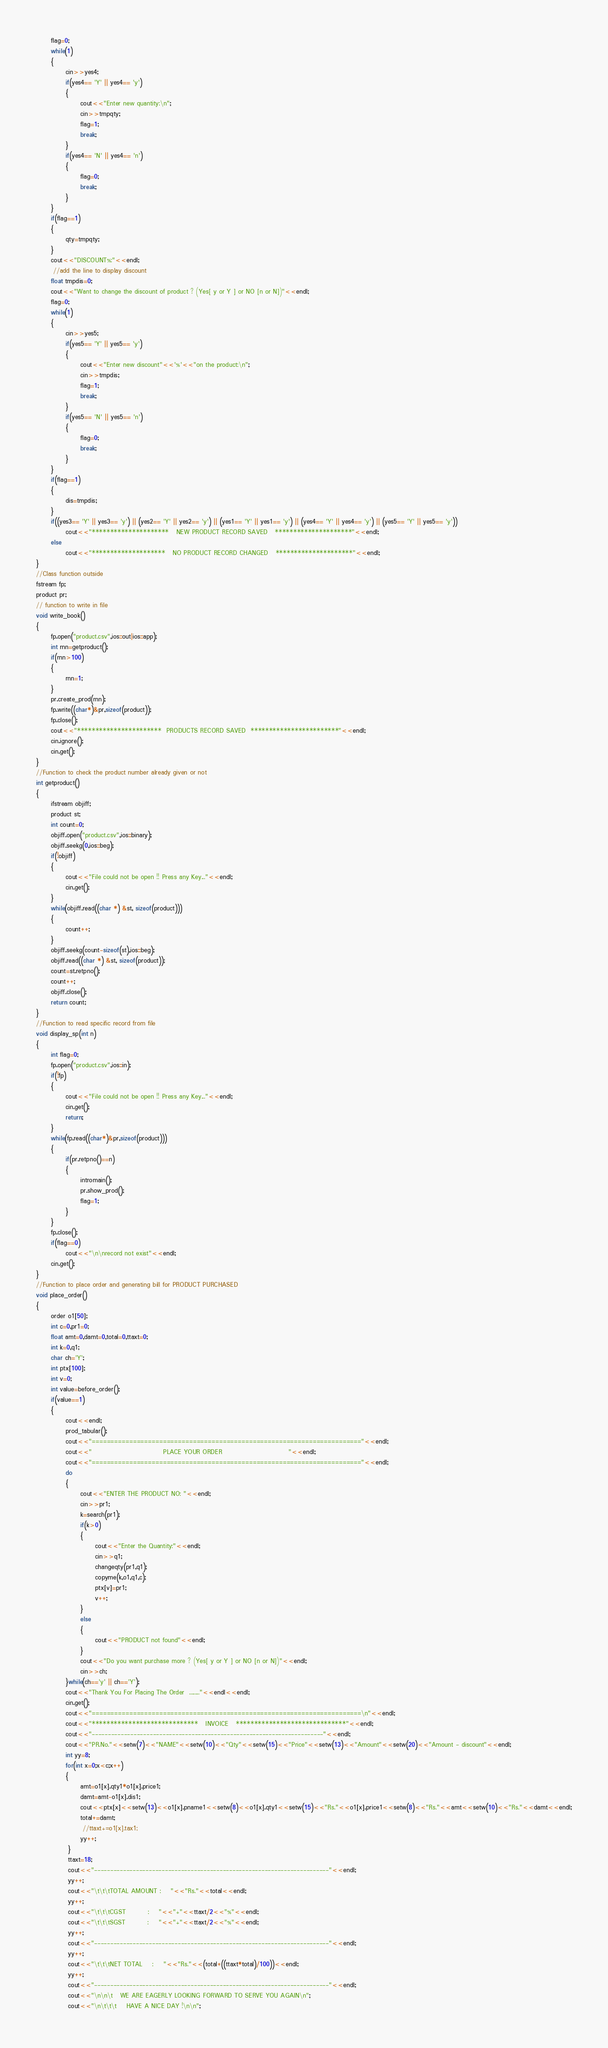Convert code to text. <code><loc_0><loc_0><loc_500><loc_500><_C++_>      flag=0;
      while(1)
      {
            cin>>yes4;
            if(yes4== 'Y' || yes4== 'y')
            {
                  cout<<"Enter new quantity:\n";
                  cin>>tmpqty;
                  flag=1;
                  break;
            }
            if(yes4== 'N' || yes4== 'n')
            {
                  flag=0;
                  break;
            }
      }
      if(flag==1)
      {
            qty=tmpqty;
      }
      cout<<"DISCOUNT%:"<<endl;
       //add the line to display discount
      float tmpdis=0;
      cout<<"Want to change the discount of product ? (Yes[ y or Y ] or NO [n or N])"<<endl;
      flag=0;
      while(1)
      {
            cin>>yes5;
            if(yes5== 'Y' || yes5== 'y')
            {
                  cout<<"Enter new discount"<<'%'<<"on the product:\n";
                  cin>>tmpdis;
                  flag=1;
                  break;
            }
            if(yes5== 'N' || yes5== 'n')
            {
                  flag=0;
                  break;
            }
      }
      if(flag==1)
      {
            dis=tmpdis;
      }
      if((yes3== 'Y' || yes3== 'y') || (yes2== 'Y' || yes2== 'y') || (yes1== 'Y' || yes1== 'y') || (yes4== 'Y' || yes4== 'y') || (yes5== 'Y' || yes5== 'y'))
            cout<<"*********************   NEW PRODUCT RECORD SAVED   *********************"<<endl;
      else
            cout<<"********************   NO PRODUCT RECORD CHANGED   *********************"<<endl;
}
//Class function outside
fstream fp;
product pr;
// function to write in file
void write_book()
{
      fp.open("product.csv",ios::out|ios::app);
      int rnn=getproduct();
      if(rnn>100)
      {
            rnn=1;
      }
      pr.create_prod(rnn);
      fp.write((char*)&pr,sizeof(product));
      fp.close();
      cout<<"***********************  PRODUCTS RECORD SAVED  ************************"<<endl;
      cin.ignore();
      cin.get();
}
//Function to check the product number already given or not
int getproduct()
{
      ifstream objiff;
      product st;
      int count=0;
      objiff.open("product.csv",ios::binary);
      objiff.seekg(0,ios::beg);
      if(!objiff)
      {
            cout<<"File could not be open !! Press any Key..."<<endl;
            cin.get();
      }
      while(objiff.read((char *) &st, sizeof(product)))
      {
            count++;
      }
      objiff.seekg(count-sizeof(st),ios::beg);
      objiff.read((char *) &st, sizeof(product));
      count=st.retpno();
      count++;
      objiff.close();
      return count;
}
//Function to read specific record from file
void display_sp(int n)
{
      int flag=0;
      fp.open("product.csv",ios::in);
      if(!fp)
      {
            cout<<"File could not be open !! Press any Key..."<<endl;
            cin.get();
            return;
      }
      while(fp.read((char*)&pr,sizeof(product)))
      {
            if(pr.retpno()==n)
            {
                  intromain();
                  pr.show_prod();
                  flag=1;
            }
      }
      fp.close();
      if(flag==0)
            cout<<"\n\nrecord not exist"<<endl;
      cin.get();
}
//Function to place order and generating bill for PRODUCT PURCHASED
void place_order()
{
      order o1[50];
      int c=0,pr1=0;
      float amt=0,damt=0,total=0,ttaxt=0;
      int k=0,q1;
      char ch='Y';
      int ptx[100];
      int v=0;
      int value=before_order();
      if(value==1)
      {
            cout<<endl;
            prod_tabular();
            cout<<"========================================================================"<<endl;
            cout<<"                             PLACE YOUR ORDER                           "<<endl;
            cout<<"========================================================================"<<endl;
            do
            {
                  cout<<"ENTER THE PRODUCT NO: "<<endl;
                  cin>>pr1;
                  k=search(pr1);
                  if(k>0)
                  {
                        cout<<"Enter the Quantity:"<<endl;
                        cin>>q1;
                        changeqty(pr1,q1);
                        copyme(k,o1,q1,c);
                        ptx[v]=pr1;
                        v++;
                  }
                  else
                  {
                        cout<<"PRODUCT not found"<<endl;
                  }
                  cout<<"Do you want purchase more ? (Yes[ y or Y ] or NO [n or N])"<<endl;
                  cin>>ch;
            }while(ch=='y' || ch=='Y');
            cout<<"Thank You For Placing The Order  ........"<<endl<<endl;
            cin.get();
            cout<<"========================================================================\n"<<endl;
            cout<<"*****************************   INVOICE   ******************************"<<endl;
            cout<<"------------------------------------------------------------------------"<<endl;
            cout<<"PR.No."<<setw(7)<<"NAME"<<setw(10)<<"Qty"<<setw(15)<<"Price"<<setw(13)<<"Amount"<<setw(20)<<"Amount - discount"<<endl;
            int yy=8;
            for(int x=0;x<c;x++)
            {
                  amt=o1[x].qty1*o1[x].price1;
                  damt=amt-o1[x].dis1;
                  cout<<ptx[x]<<setw(13)<<o1[x].pname1<<setw(8)<<o1[x].qty1<<setw(15)<<"Rs."<<o1[x].price1<<setw(8)<<"Rs."<<amt<<setw(10)<<"Rs."<<damt<<endl;
                  total+=damt;
                   //ttaxt+=o1[x].tax1;
                  yy++;
             }
             ttaxt=18;
             cout<<"-------------------------------------------------------------------------"<<endl;
             yy++;
             cout<<"\t\t\tTOTAL AMOUNT :    "<<"Rs."<<total<<endl;
             yy++;
             cout<<"\t\t\tCGST         :    "<<"+"<<ttaxt/2<<"%"<<endl;
             cout<<"\t\t\tSGST         :    "<<"+"<<ttaxt/2<<"%"<<endl;
             yy++;
             cout<<"-------------------------------------------------------------------------"<<endl;
             yy++;
             cout<<"\t\t\tNET TOTAL    :    "<<"Rs."<<(total+((ttaxt*total)/100))<<endl;
             yy++;
             cout<<"-------------------------------------------------------------------------"<<endl;
             cout<<"\n\n\t   WE ARE EAGERLY LOOKING FORWARD TO SERVE YOU AGAIN\n";
             cout<<"\n\t\t\t    HAVE A NICE DAY !\n\n";</code> 